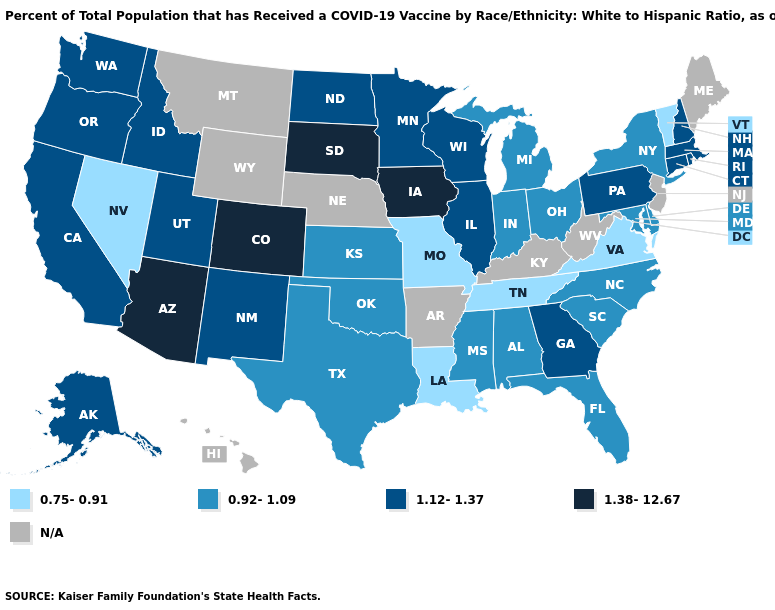Among the states that border Michigan , which have the highest value?
Quick response, please. Wisconsin. Name the states that have a value in the range 0.75-0.91?
Short answer required. Louisiana, Missouri, Nevada, Tennessee, Vermont, Virginia. What is the value of Vermont?
Be succinct. 0.75-0.91. How many symbols are there in the legend?
Give a very brief answer. 5. What is the lowest value in the USA?
Write a very short answer. 0.75-0.91. What is the value of Arizona?
Write a very short answer. 1.38-12.67. What is the value of Alaska?
Quick response, please. 1.12-1.37. Among the states that border Michigan , does Ohio have the lowest value?
Keep it brief. Yes. What is the lowest value in the South?
Quick response, please. 0.75-0.91. What is the value of Kansas?
Write a very short answer. 0.92-1.09. Name the states that have a value in the range N/A?
Be succinct. Arkansas, Hawaii, Kentucky, Maine, Montana, Nebraska, New Jersey, West Virginia, Wyoming. Which states have the lowest value in the South?
Short answer required. Louisiana, Tennessee, Virginia. Name the states that have a value in the range 1.38-12.67?
Quick response, please. Arizona, Colorado, Iowa, South Dakota. What is the highest value in states that border Connecticut?
Give a very brief answer. 1.12-1.37. How many symbols are there in the legend?
Quick response, please. 5. 